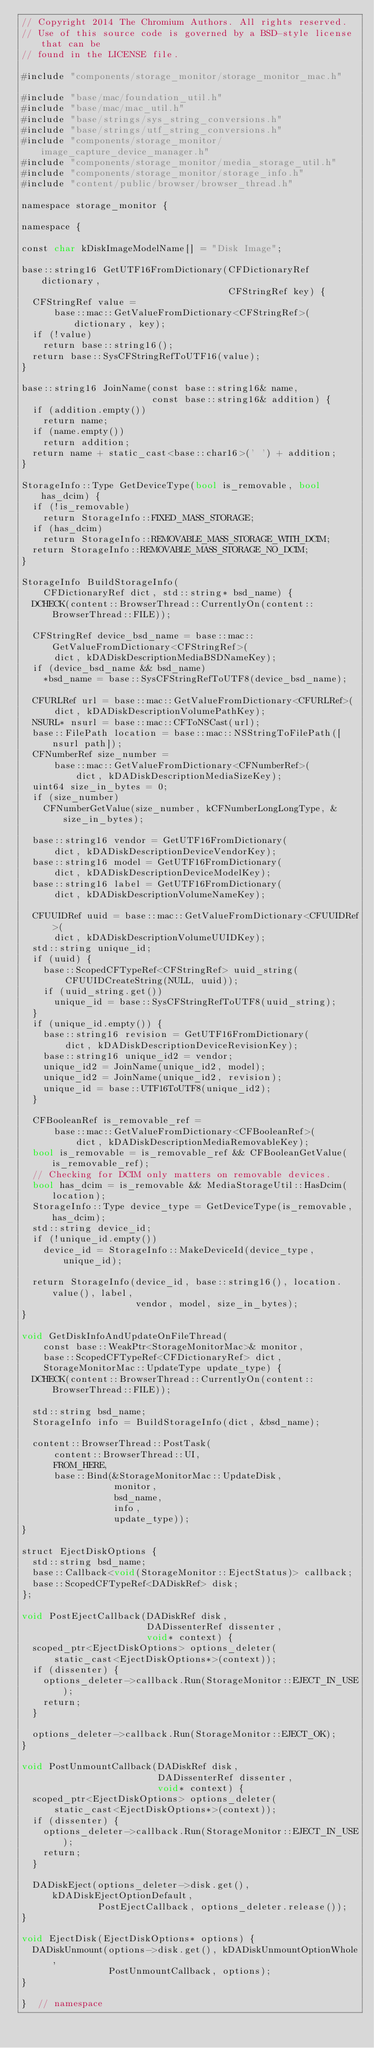Convert code to text. <code><loc_0><loc_0><loc_500><loc_500><_ObjectiveC_>// Copyright 2014 The Chromium Authors. All rights reserved.
// Use of this source code is governed by a BSD-style license that can be
// found in the LICENSE file.

#include "components/storage_monitor/storage_monitor_mac.h"

#include "base/mac/foundation_util.h"
#include "base/mac/mac_util.h"
#include "base/strings/sys_string_conversions.h"
#include "base/strings/utf_string_conversions.h"
#include "components/storage_monitor/image_capture_device_manager.h"
#include "components/storage_monitor/media_storage_util.h"
#include "components/storage_monitor/storage_info.h"
#include "content/public/browser/browser_thread.h"

namespace storage_monitor {

namespace {

const char kDiskImageModelName[] = "Disk Image";

base::string16 GetUTF16FromDictionary(CFDictionaryRef dictionary,
                                      CFStringRef key) {
  CFStringRef value =
      base::mac::GetValueFromDictionary<CFStringRef>(dictionary, key);
  if (!value)
    return base::string16();
  return base::SysCFStringRefToUTF16(value);
}

base::string16 JoinName(const base::string16& name,
                        const base::string16& addition) {
  if (addition.empty())
    return name;
  if (name.empty())
    return addition;
  return name + static_cast<base::char16>(' ') + addition;
}

StorageInfo::Type GetDeviceType(bool is_removable, bool has_dcim) {
  if (!is_removable)
    return StorageInfo::FIXED_MASS_STORAGE;
  if (has_dcim)
    return StorageInfo::REMOVABLE_MASS_STORAGE_WITH_DCIM;
  return StorageInfo::REMOVABLE_MASS_STORAGE_NO_DCIM;
}

StorageInfo BuildStorageInfo(
    CFDictionaryRef dict, std::string* bsd_name) {
  DCHECK(content::BrowserThread::CurrentlyOn(content::BrowserThread::FILE));

  CFStringRef device_bsd_name = base::mac::GetValueFromDictionary<CFStringRef>(
      dict, kDADiskDescriptionMediaBSDNameKey);
  if (device_bsd_name && bsd_name)
    *bsd_name = base::SysCFStringRefToUTF8(device_bsd_name);

  CFURLRef url = base::mac::GetValueFromDictionary<CFURLRef>(
      dict, kDADiskDescriptionVolumePathKey);
  NSURL* nsurl = base::mac::CFToNSCast(url);
  base::FilePath location = base::mac::NSStringToFilePath([nsurl path]);
  CFNumberRef size_number =
      base::mac::GetValueFromDictionary<CFNumberRef>(
          dict, kDADiskDescriptionMediaSizeKey);
  uint64 size_in_bytes = 0;
  if (size_number)
    CFNumberGetValue(size_number, kCFNumberLongLongType, &size_in_bytes);

  base::string16 vendor = GetUTF16FromDictionary(
      dict, kDADiskDescriptionDeviceVendorKey);
  base::string16 model = GetUTF16FromDictionary(
      dict, kDADiskDescriptionDeviceModelKey);
  base::string16 label = GetUTF16FromDictionary(
      dict, kDADiskDescriptionVolumeNameKey);

  CFUUIDRef uuid = base::mac::GetValueFromDictionary<CFUUIDRef>(
      dict, kDADiskDescriptionVolumeUUIDKey);
  std::string unique_id;
  if (uuid) {
    base::ScopedCFTypeRef<CFStringRef> uuid_string(
        CFUUIDCreateString(NULL, uuid));
    if (uuid_string.get())
      unique_id = base::SysCFStringRefToUTF8(uuid_string);
  }
  if (unique_id.empty()) {
    base::string16 revision = GetUTF16FromDictionary(
        dict, kDADiskDescriptionDeviceRevisionKey);
    base::string16 unique_id2 = vendor;
    unique_id2 = JoinName(unique_id2, model);
    unique_id2 = JoinName(unique_id2, revision);
    unique_id = base::UTF16ToUTF8(unique_id2);
  }

  CFBooleanRef is_removable_ref =
      base::mac::GetValueFromDictionary<CFBooleanRef>(
          dict, kDADiskDescriptionMediaRemovableKey);
  bool is_removable = is_removable_ref && CFBooleanGetValue(is_removable_ref);
  // Checking for DCIM only matters on removable devices.
  bool has_dcim = is_removable && MediaStorageUtil::HasDcim(location);
  StorageInfo::Type device_type = GetDeviceType(is_removable, has_dcim);
  std::string device_id;
  if (!unique_id.empty())
    device_id = StorageInfo::MakeDeviceId(device_type, unique_id);

  return StorageInfo(device_id, base::string16(), location.value(), label,
                     vendor, model, size_in_bytes);
}

void GetDiskInfoAndUpdateOnFileThread(
    const base::WeakPtr<StorageMonitorMac>& monitor,
    base::ScopedCFTypeRef<CFDictionaryRef> dict,
    StorageMonitorMac::UpdateType update_type) {
  DCHECK(content::BrowserThread::CurrentlyOn(content::BrowserThread::FILE));

  std::string bsd_name;
  StorageInfo info = BuildStorageInfo(dict, &bsd_name);

  content::BrowserThread::PostTask(
      content::BrowserThread::UI,
      FROM_HERE,
      base::Bind(&StorageMonitorMac::UpdateDisk,
                 monitor,
                 bsd_name,
                 info,
                 update_type));
}

struct EjectDiskOptions {
  std::string bsd_name;
  base::Callback<void(StorageMonitor::EjectStatus)> callback;
  base::ScopedCFTypeRef<DADiskRef> disk;
};

void PostEjectCallback(DADiskRef disk,
                       DADissenterRef dissenter,
                       void* context) {
  scoped_ptr<EjectDiskOptions> options_deleter(
      static_cast<EjectDiskOptions*>(context));
  if (dissenter) {
    options_deleter->callback.Run(StorageMonitor::EJECT_IN_USE);
    return;
  }

  options_deleter->callback.Run(StorageMonitor::EJECT_OK);
}

void PostUnmountCallback(DADiskRef disk,
                         DADissenterRef dissenter,
                         void* context) {
  scoped_ptr<EjectDiskOptions> options_deleter(
      static_cast<EjectDiskOptions*>(context));
  if (dissenter) {
    options_deleter->callback.Run(StorageMonitor::EJECT_IN_USE);
    return;
  }

  DADiskEject(options_deleter->disk.get(), kDADiskEjectOptionDefault,
              PostEjectCallback, options_deleter.release());
}

void EjectDisk(EjectDiskOptions* options) {
  DADiskUnmount(options->disk.get(), kDADiskUnmountOptionWhole,
                PostUnmountCallback, options);
}

}  // namespace
</code> 